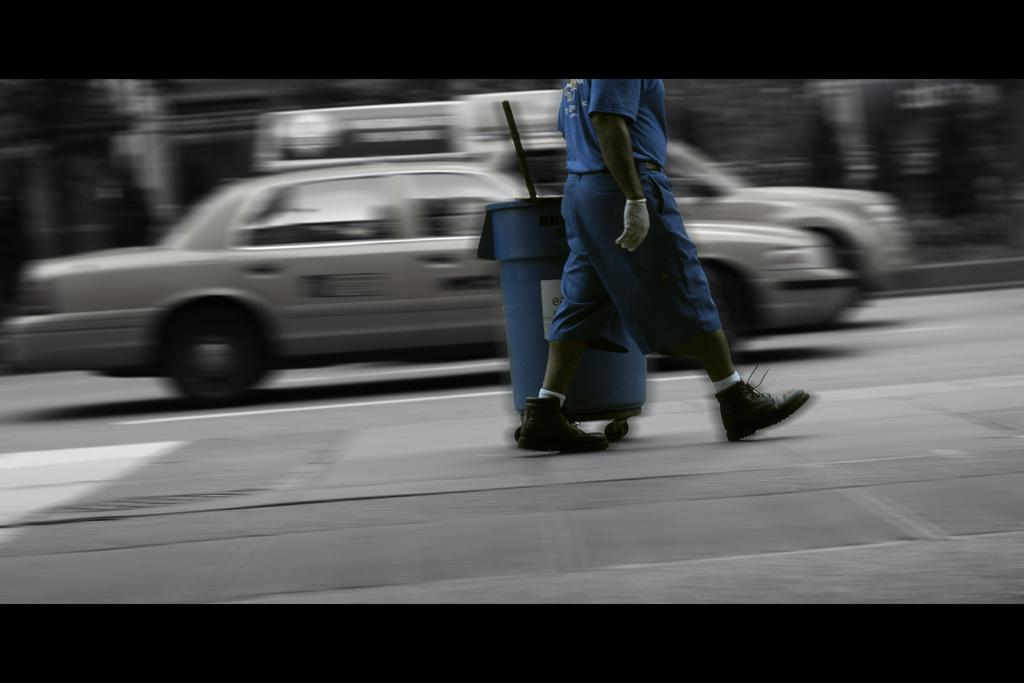What is the person in the image doing? There is a person walking in the image. What object can be seen near the person? There is a dustbin in the image. What else is visible in the image besides the person and the dustbin? There are vehicles on the road in the image. Can you describe the background of the image? The background appears blurry. How many houses can be seen in the image? There are no houses visible in the image. What type of drain is present in the image? There is no drain present in the image. 